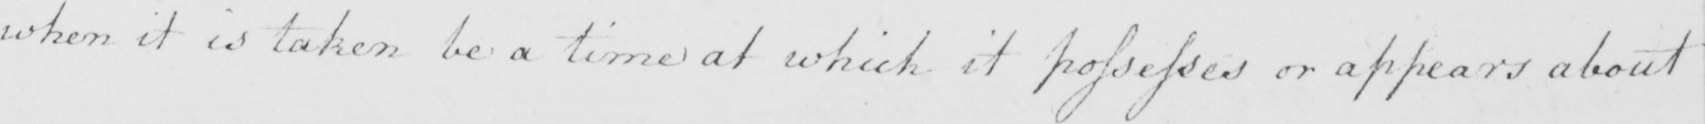What is written in this line of handwriting? when it is taken be a time at which it possesses or appears about 